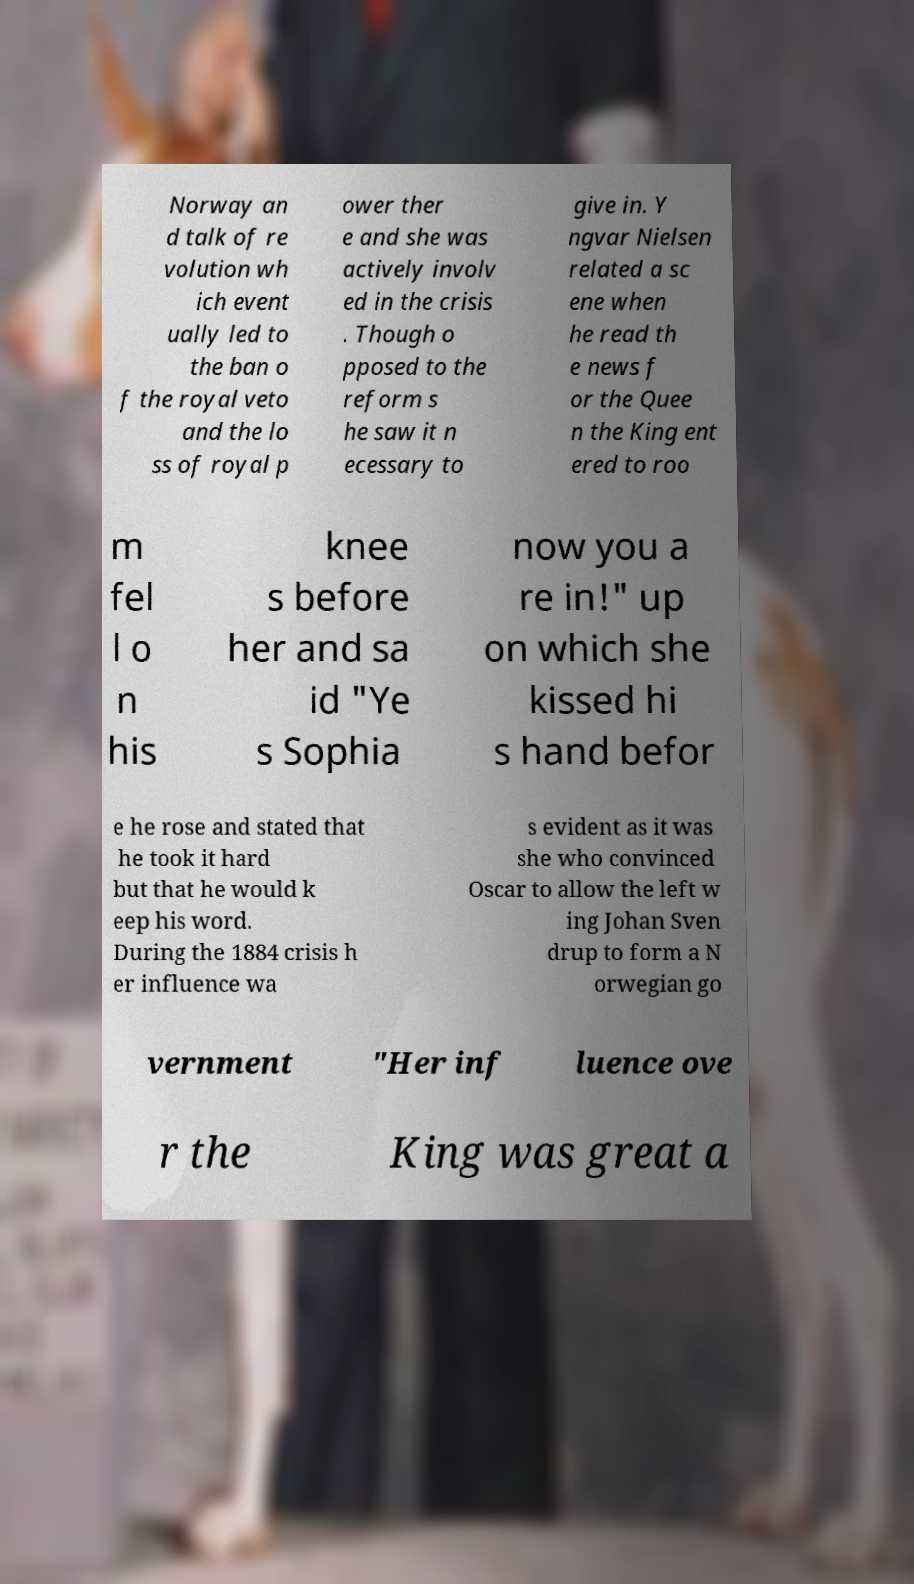What messages or text are displayed in this image? I need them in a readable, typed format. Norway an d talk of re volution wh ich event ually led to the ban o f the royal veto and the lo ss of royal p ower ther e and she was actively involv ed in the crisis . Though o pposed to the reform s he saw it n ecessary to give in. Y ngvar Nielsen related a sc ene when he read th e news f or the Quee n the King ent ered to roo m fel l o n his knee s before her and sa id "Ye s Sophia now you a re in!" up on which she kissed hi s hand befor e he rose and stated that he took it hard but that he would k eep his word. During the 1884 crisis h er influence wa s evident as it was she who convinced Oscar to allow the left w ing Johan Sven drup to form a N orwegian go vernment "Her inf luence ove r the King was great a 